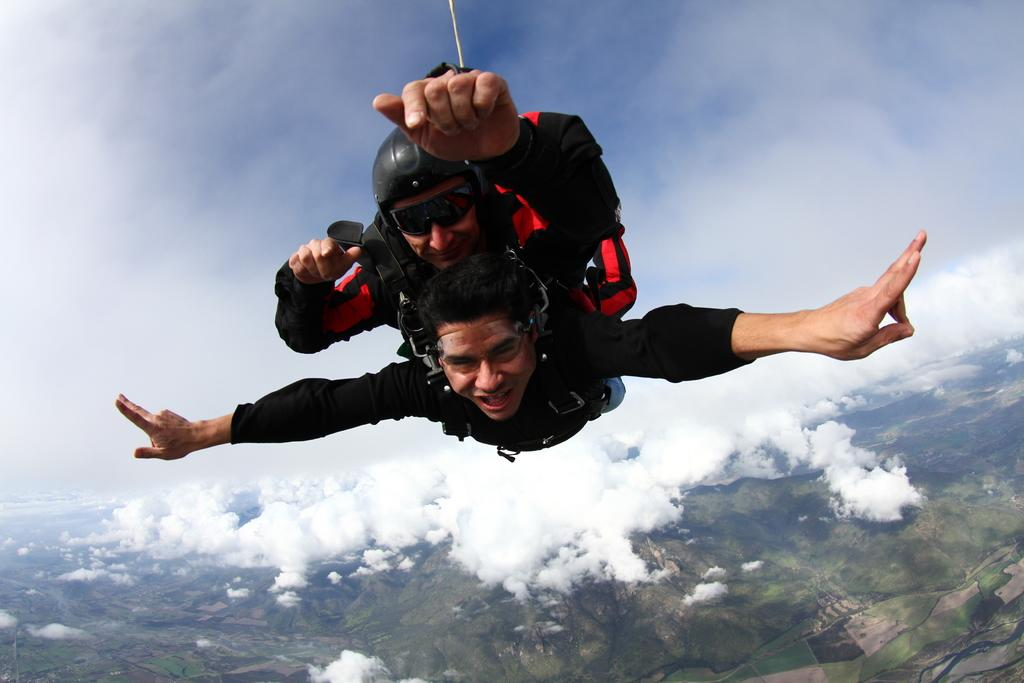How many people are in the image? There are two persons in the image. What are the persons doing in the image? The persons are flying in the sky. What can be seen at the bottom of the image? There are mountains at the bottom of the image. What is visible at the top of the image? The sky is visible at the top of the image. What can be observed in the sky? There are clouds in the sky. What type of impulse is causing the person to expand in the image? There is no person expanding in the image, and therefore no impulse causing such an action. 